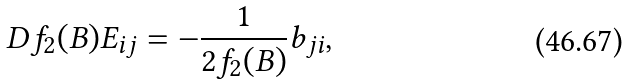<formula> <loc_0><loc_0><loc_500><loc_500>D f _ { 2 } ( B ) E _ { i j } = - \frac { 1 } { 2 f _ { 2 } ( B ) } b _ { j i } ,</formula> 